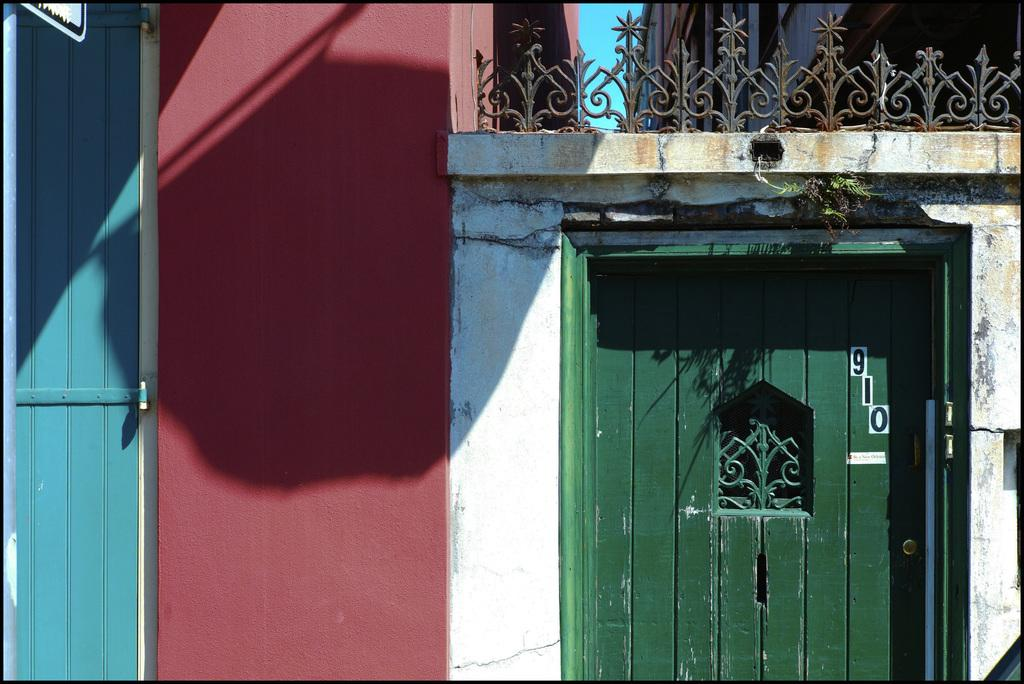What color is the door in the image? The door in the image is green. What colors can be seen on the buildings in the image? The buildings in the image have some in pink and brown colors. What feature is present in the image that might be used for support or safety? There is a railing visible in the image. What is the color of the sky in the image? The sky is blue in the image. How many accounts are mentioned in the image? There are no accounts mentioned in the image. What type of operation is being performed in the image? There is no operation being performed in the image. 